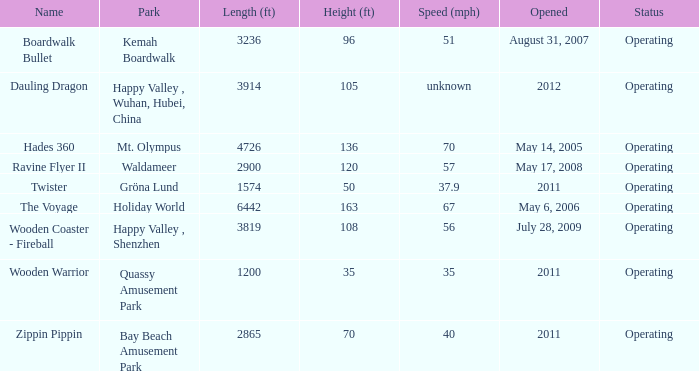How fast is the coaster that is 163 feet tall 67.0. 